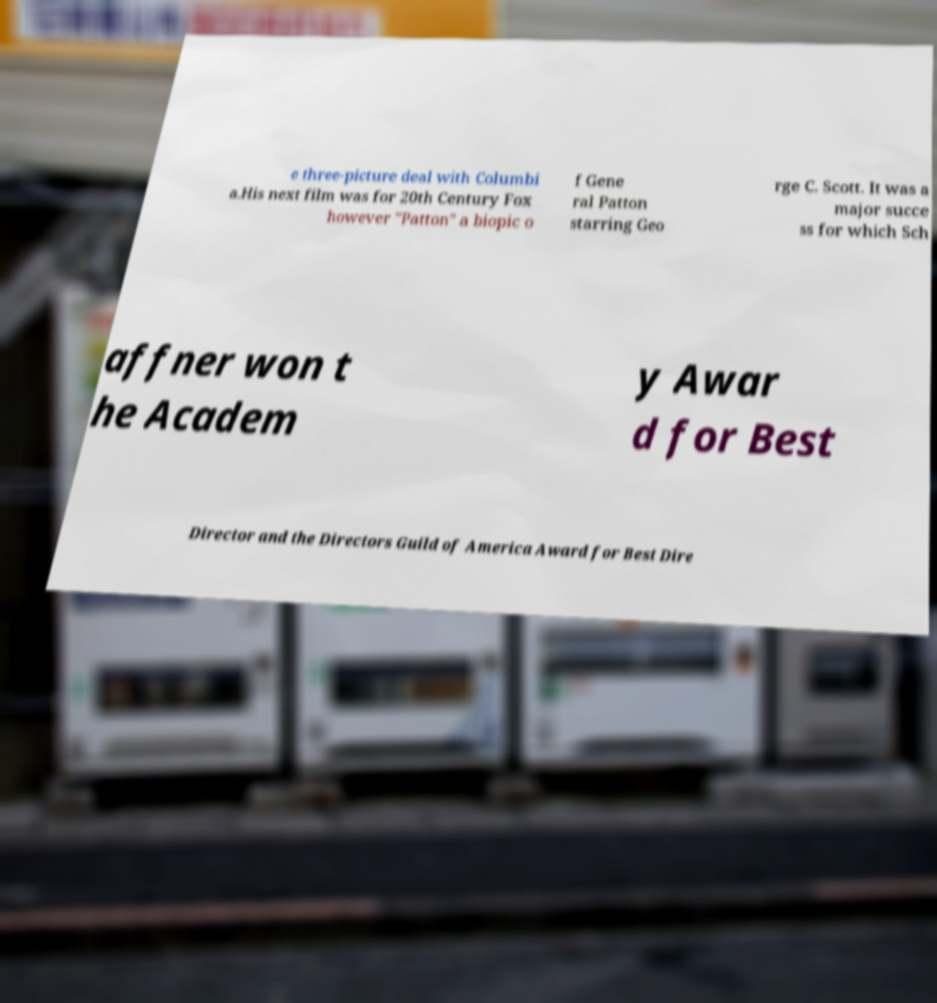Could you assist in decoding the text presented in this image and type it out clearly? e three-picture deal with Columbi a.His next film was for 20th Century Fox however "Patton" a biopic o f Gene ral Patton starring Geo rge C. Scott. It was a major succe ss for which Sch affner won t he Academ y Awar d for Best Director and the Directors Guild of America Award for Best Dire 